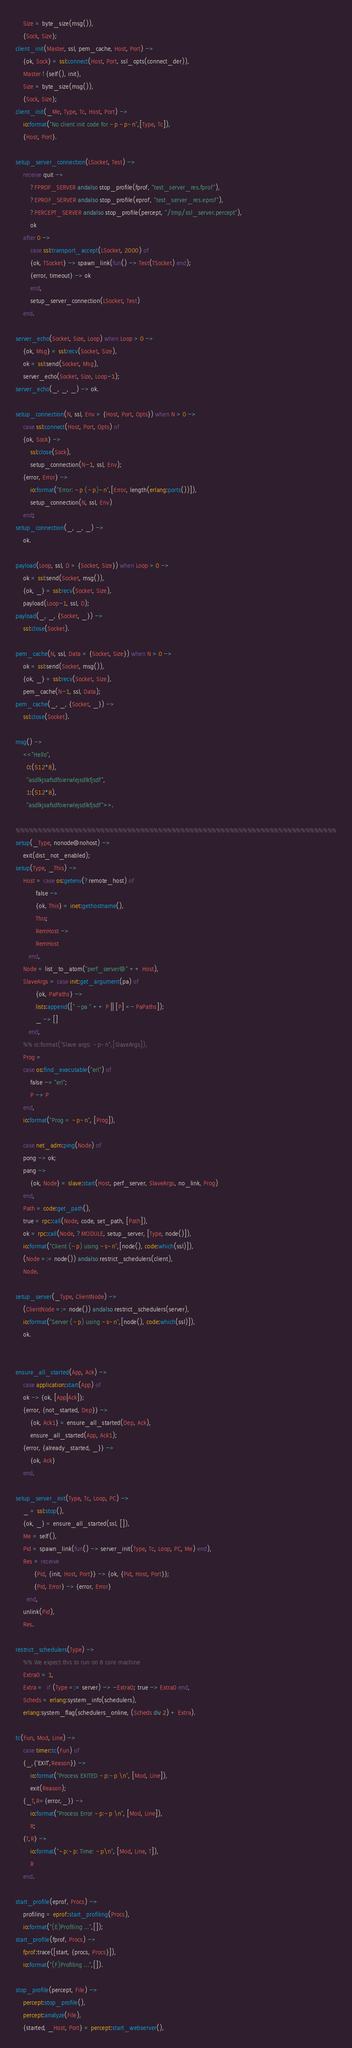Convert code to text. <code><loc_0><loc_0><loc_500><loc_500><_Erlang_>    Size = byte_size(msg()),
    {Sock, Size};
client_init(Master, ssl, pem_cache, Host, Port) ->
    {ok, Sock} = ssl:connect(Host, Port, ssl_opts(connect_der)),
    Master ! {self(), init},
    Size = byte_size(msg()),
    {Sock, Size};
client_init(_Me, Type, Tc, Host, Port) ->
    io:format("No client init code for ~p ~p~n",[Type, Tc]),
    {Host, Port}.

setup_server_connection(LSocket, Test) ->
    receive quit ->
	    ?FPROF_SERVER andalso stop_profile(fprof, "test_server_res.fprof"),
	    ?EPROF_SERVER andalso stop_profile(eprof, "test_server_res.eprof"),
	    ?PERCEPT_SERVER andalso stop_profile(percept, "/tmp/ssl_server.percept"),
	    ok
    after 0 ->
	    case ssl:transport_accept(LSocket, 2000) of
		{ok, TSocket} -> spawn_link(fun() -> Test(TSocket) end);
		{error, timeout} -> ok
	    end,
	    setup_server_connection(LSocket, Test)
    end.

server_echo(Socket, Size, Loop) when Loop > 0 ->
    {ok, Msg} = ssl:recv(Socket, Size),
    ok = ssl:send(Socket, Msg),
    server_echo(Socket, Size, Loop-1);
server_echo(_, _, _) -> ok.

setup_connection(N, ssl, Env = {Host, Port, Opts}) when N > 0 ->
    case ssl:connect(Host, Port, Opts) of
	{ok, Sock} ->
	    ssl:close(Sock),
	    setup_connection(N-1, ssl, Env);
	{error, Error} ->
	    io:format("Error: ~p (~p)~n",[Error, length(erlang:ports())]),
	    setup_connection(N, ssl, Env)
    end;
setup_connection(_, _, _) ->
    ok.

payload(Loop, ssl, D = {Socket, Size}) when Loop > 0 ->
    ok = ssl:send(Socket, msg()),
    {ok, _} = ssl:recv(Socket, Size),
    payload(Loop-1, ssl, D);
payload(_, _, {Socket, _}) ->
    ssl:close(Socket).

pem_cache(N, ssl, Data = {Socket, Size}) when N > 0 ->
    ok = ssl:send(Socket, msg()),
    {ok, _} = ssl:recv(Socket, Size),
    pem_cache(N-1, ssl, Data);
pem_cache(_, _, {Socket, _}) ->
    ssl:close(Socket).

msg() ->
    <<"Hello", 
      0:(512*8), 
      "asdlkjsafsdfoierwlejsdlkfjsdf", 
      1:(512*8),
      "asdlkjsafsdfoierwlejsdlkfjsdf">>.

%%%%%%%%%%%%%%%%%%%%%%%%%%%%%%%%%%%%%%%%%%%%%%%%%%%%%%%%%%%%%%%%%%%%%%%%
setup(_Type, nonode@nohost) ->
    exit(dist_not_enabled);
setup(Type, _This) ->
    Host = case os:getenv(?remote_host) of
	       false ->
		   {ok, This} = inet:gethostname(),
		   This;
	       RemHost ->
		   RemHost
	   end,
    Node = list_to_atom("perf_server@" ++ Host),
    SlaveArgs = case init:get_argument(pa) of
	       {ok, PaPaths} ->
		   lists:append([" -pa " ++ P || [P] <- PaPaths]);
	       _ -> []
	   end,
    %% io:format("Slave args: ~p~n",[SlaveArgs]),
    Prog =
	case os:find_executable("erl") of
	    false -> "erl";
	    P -> P
	end,
    io:format("Prog = ~p~n", [Prog]),

    case net_adm:ping(Node) of
	pong -> ok;
	pang ->
	    {ok, Node} = slave:start(Host, perf_server, SlaveArgs, no_link, Prog)
    end,
    Path = code:get_path(),
    true = rpc:call(Node, code, set_path, [Path]),
    ok = rpc:call(Node, ?MODULE, setup_server, [Type, node()]),
    io:format("Client (~p) using ~s~n",[node(), code:which(ssl)]),
    (Node =:= node()) andalso restrict_schedulers(client),
    Node.

setup_server(_Type, ClientNode) ->
    (ClientNode =:= node()) andalso restrict_schedulers(server),
    io:format("Server (~p) using ~s~n",[node(), code:which(ssl)]),
    ok.


ensure_all_started(App, Ack) ->
    case application:start(App) of
	ok -> {ok, [App|Ack]};
	{error, {not_started, Dep}} ->
	    {ok, Ack1} = ensure_all_started(Dep, Ack),
	    ensure_all_started(App, Ack1);
	{error, {already_started, _}} ->
	    {ok, Ack}
    end.

setup_server_init(Type, Tc, Loop, PC) ->
    _ = ssl:stop(),
    {ok, _} = ensure_all_started(ssl, []),
    Me = self(),
    Pid = spawn_link(fun() -> server_init(Type, Tc, Loop, PC, Me) end),
    Res = receive
	      {Pid, {init, Host, Port}} -> {ok, {Pid, Host, Port}};
	      {Pid, Error} -> {error, Error}
	  end,
    unlink(Pid),
    Res.

restrict_schedulers(Type) ->
    %% We expect this to run on 8 core machine
    Extra0 = 1,
    Extra =  if (Type =:= server) -> -Extra0; true -> Extra0 end,
    Scheds = erlang:system_info(schedulers),
    erlang:system_flag(schedulers_online, (Scheds div 2) + Extra).

tc(Fun, Mod, Line) ->
    case timer:tc(Fun) of
	{_,{'EXIT',Reason}} ->
	    io:format("Process EXITED ~p:~p \n", [Mod, Line]),
	    exit(Reason);
	{_T,R={error,_}} ->
	    io:format("Process Error ~p:~p \n", [Mod, Line]),
	    R;
	{T,R} ->
	    io:format("~p:~p: Time: ~p\n", [Mod, Line, T]),
	    R
    end.

start_profile(eprof, Procs) ->
    profiling = eprof:start_profiling(Procs),
    io:format("(E)Profiling ...",[]);
start_profile(fprof, Procs) ->
    fprof:trace([start, {procs, Procs}]),
    io:format("(F)Profiling ...",[]).

stop_profile(percept, File) ->
    percept:stop_profile(),
    percept:analyze(File),
    {started, _Host, Port} = percept:start_webserver(),</code> 